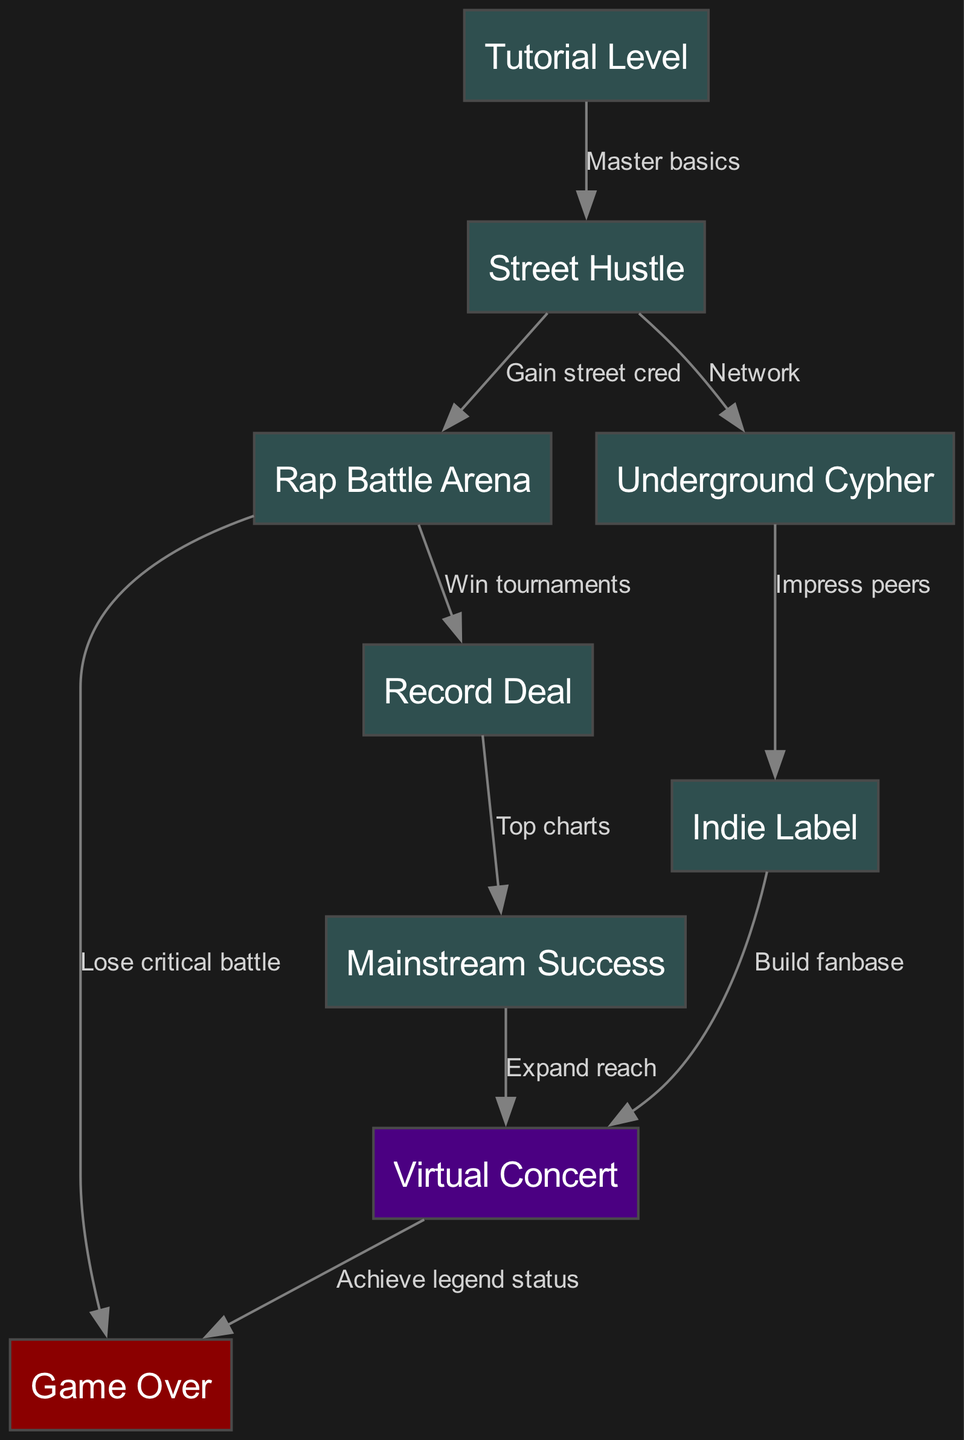What is the starting point of the storyline? The starting point is indicated by the first node in the diagram, which is "Tutorial Level." This is where the player begins their journey in the video game.
Answer: Tutorial Level How many total nodes are in the graph? To find the total nodes, we count each unique node listed in the diagram. The nodes are: "Tutorial Level," "Street Hustle," "Rap Battle Arena," "Underground Cypher," "Record Deal," "Mainstream Success," "Indie Label," "Virtual Concert," and "Game Over." This sums to 9 nodes.
Answer: 9 What leads to "Mainstream Success"? We look for edges that connect to "Mainstream Success." The connecting edge is from "Record Deal," indicated by the label "Top charts." This shows that achieving a record deal is the route to mainstream success.
Answer: Record Deal What is the consequence of losing a critical battle? The diagram specifies that losing a critical battle at the "Rap Battle Arena" leads directly to "Game Over." This shows a failure path in the storyline.
Answer: Game Over What happens after achieving a virtual concert? The edge from "Virtual Concert" points to "Game Over" with the label "Achieve legend status." This implies that completing a virtual concert concludes the journey and marks the player's success in achieving legendary status.
Answer: Game Over How do you reach the Indie Label? The Indie Label can be reached by impressing peers at the "Underground Cypher," as indicated by the edge connecting these two nodes. This path highlights an option for career progression in the game focused on indie music.
Answer: Underground Cypher What is the label associated with gaining street cred? The edge from "Street Hustle" to "Rap Battle Arena" has the label "Gain street cred." This phrase indicates that gaining street credibility is necessary for progressing to the rap battle stage.
Answer: Gain street cred How do players expand their reach after mainstream success? The path from "Mainstream Success" to "Virtual Concert" indicates the next step towards expanding reach, showing that players can showcase their music to a larger audience. The label for this edge is "Expand reach."
Answer: Virtual Concert What are the different paths leading to Game Over? There are two paths leading to "Game Over." One is from "Virtual Concert," where the label is "Achieve legend status," and the other is from "Rap Battle Arena," with the label "Lose critical battle." Combining these paths illustrates different outcomes leading to the same conclusion of game over.
Answer: Virtual Concert and Rap Battle Arena 